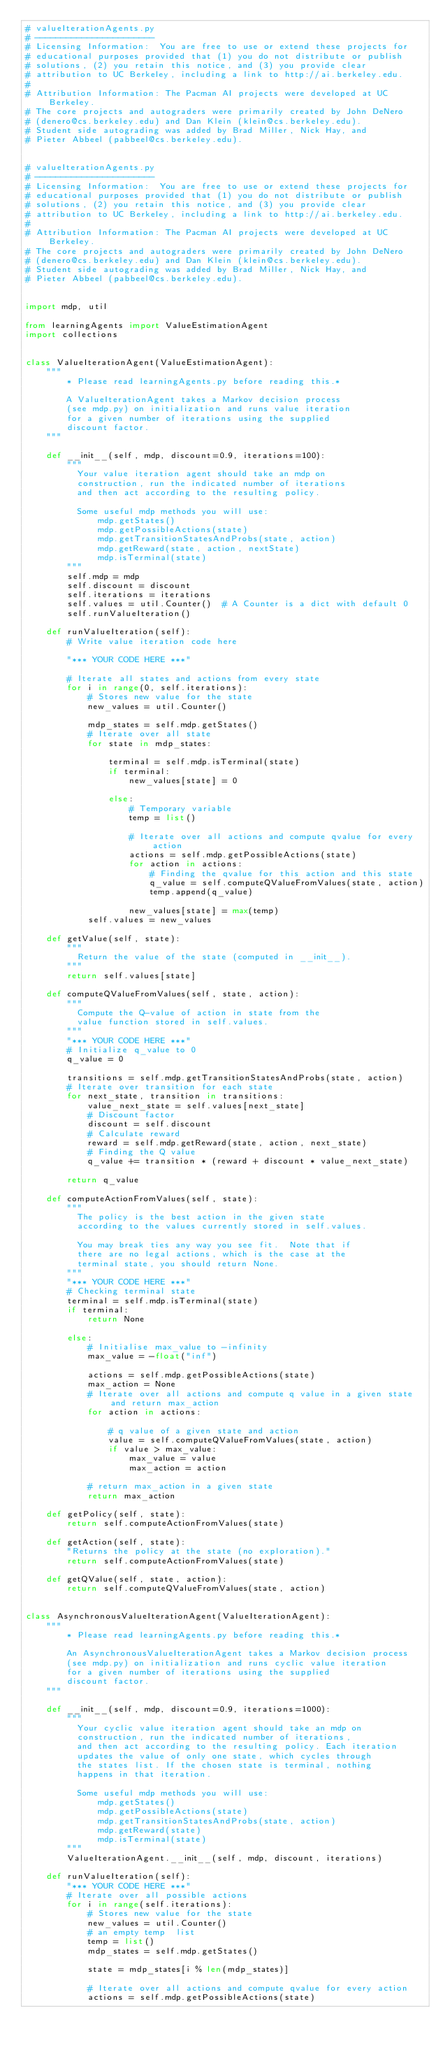<code> <loc_0><loc_0><loc_500><loc_500><_Python_># valueIterationAgents.py
# -----------------------
# Licensing Information:  You are free to use or extend these projects for
# educational purposes provided that (1) you do not distribute or publish
# solutions, (2) you retain this notice, and (3) you provide clear
# attribution to UC Berkeley, including a link to http://ai.berkeley.edu.
# 
# Attribution Information: The Pacman AI projects were developed at UC Berkeley.
# The core projects and autograders were primarily created by John DeNero
# (denero@cs.berkeley.edu) and Dan Klein (klein@cs.berkeley.edu).
# Student side autograding was added by Brad Miller, Nick Hay, and
# Pieter Abbeel (pabbeel@cs.berkeley.edu).


# valueIterationAgents.py
# -----------------------
# Licensing Information:  You are free to use or extend these projects for
# educational purposes provided that (1) you do not distribute or publish
# solutions, (2) you retain this notice, and (3) you provide clear
# attribution to UC Berkeley, including a link to http://ai.berkeley.edu.
# 
# Attribution Information: The Pacman AI projects were developed at UC Berkeley.
# The core projects and autograders were primarily created by John DeNero
# (denero@cs.berkeley.edu) and Dan Klein (klein@cs.berkeley.edu).
# Student side autograding was added by Brad Miller, Nick Hay, and
# Pieter Abbeel (pabbeel@cs.berkeley.edu).


import mdp, util

from learningAgents import ValueEstimationAgent
import collections


class ValueIterationAgent(ValueEstimationAgent):
    """
        * Please read learningAgents.py before reading this.*

        A ValueIterationAgent takes a Markov decision process
        (see mdp.py) on initialization and runs value iteration
        for a given number of iterations using the supplied
        discount factor.
    """

    def __init__(self, mdp, discount=0.9, iterations=100):
        """
          Your value iteration agent should take an mdp on
          construction, run the indicated number of iterations
          and then act according to the resulting policy.

          Some useful mdp methods you will use:
              mdp.getStates()
              mdp.getPossibleActions(state)
              mdp.getTransitionStatesAndProbs(state, action)
              mdp.getReward(state, action, nextState)
              mdp.isTerminal(state)
        """
        self.mdp = mdp
        self.discount = discount
        self.iterations = iterations
        self.values = util.Counter()  # A Counter is a dict with default 0
        self.runValueIteration()

    def runValueIteration(self):
        # Write value iteration code here

        "*** YOUR CODE HERE ***"

        # Iterate all states and actions from every state
        for i in range(0, self.iterations):
            # Stores new value for the state
            new_values = util.Counter()

            mdp_states = self.mdp.getStates()
            # Iterate over all state
            for state in mdp_states:

                terminal = self.mdp.isTerminal(state)
                if terminal:
                    new_values[state] = 0

                else:
                    # Temporary variable
                    temp = list()

                    # Iterate over all actions and compute qvalue for every action
                    actions = self.mdp.getPossibleActions(state)
                    for action in actions:
                        # Finding the qvalue for this action and this state
                        q_value = self.computeQValueFromValues(state, action)
                        temp.append(q_value)

                    new_values[state] = max(temp)
            self.values = new_values

    def getValue(self, state):
        """
          Return the value of the state (computed in __init__).
        """
        return self.values[state]

    def computeQValueFromValues(self, state, action):
        """
          Compute the Q-value of action in state from the
          value function stored in self.values.
        """
        "*** YOUR CODE HERE ***"
        # Initialize q_value to 0
        q_value = 0

        transitions = self.mdp.getTransitionStatesAndProbs(state, action)
        # Iterate over transition for each state
        for next_state, transition in transitions:
            value_next_state = self.values[next_state]
            # Discount factor
            discount = self.discount
            # Calculate reward
            reward = self.mdp.getReward(state, action, next_state)
            # Finding the Q value
            q_value += transition * (reward + discount * value_next_state)

        return q_value

    def computeActionFromValues(self, state):
        """
          The policy is the best action in the given state
          according to the values currently stored in self.values.

          You may break ties any way you see fit.  Note that if
          there are no legal actions, which is the case at the
          terminal state, you should return None.
        """
        "*** YOUR CODE HERE ***"
        # Checking terminal state
        terminal = self.mdp.isTerminal(state)
        if terminal:
            return None

        else:
            # Initialise max_value to -infinity
            max_value = -float("inf")

            actions = self.mdp.getPossibleActions(state)
            max_action = None
            # Iterate over all actions and compute q value in a given state and return max_action
            for action in actions:

                # q value of a given state and action
                value = self.computeQValueFromValues(state, action)
                if value > max_value:
                    max_value = value
                    max_action = action

            # return max_action in a given state
            return max_action

    def getPolicy(self, state):
        return self.computeActionFromValues(state)

    def getAction(self, state):
        "Returns the policy at the state (no exploration)."
        return self.computeActionFromValues(state)

    def getQValue(self, state, action):
        return self.computeQValueFromValues(state, action)


class AsynchronousValueIterationAgent(ValueIterationAgent):
    """
        * Please read learningAgents.py before reading this.*

        An AsynchronousValueIterationAgent takes a Markov decision process
        (see mdp.py) on initialization and runs cyclic value iteration
        for a given number of iterations using the supplied
        discount factor.
    """

    def __init__(self, mdp, discount=0.9, iterations=1000):
        """
          Your cyclic value iteration agent should take an mdp on
          construction, run the indicated number of iterations,
          and then act according to the resulting policy. Each iteration
          updates the value of only one state, which cycles through
          the states list. If the chosen state is terminal, nothing
          happens in that iteration.

          Some useful mdp methods you will use:
              mdp.getStates()
              mdp.getPossibleActions(state)
              mdp.getTransitionStatesAndProbs(state, action)
              mdp.getReward(state)
              mdp.isTerminal(state)
        """
        ValueIterationAgent.__init__(self, mdp, discount, iterations)

    def runValueIteration(self):
        "*** YOUR CODE HERE ***"
        # Iterate over all possible actions
        for i in range(self.iterations):
            # Stores new value for the state
            new_values = util.Counter()
            # an empty temp  list
            temp = list()
            mdp_states = self.mdp.getStates()

            state = mdp_states[i % len(mdp_states)]

            # Iterate over all actions and compute qvalue for every action
            actions = self.mdp.getPossibleActions(state)</code> 